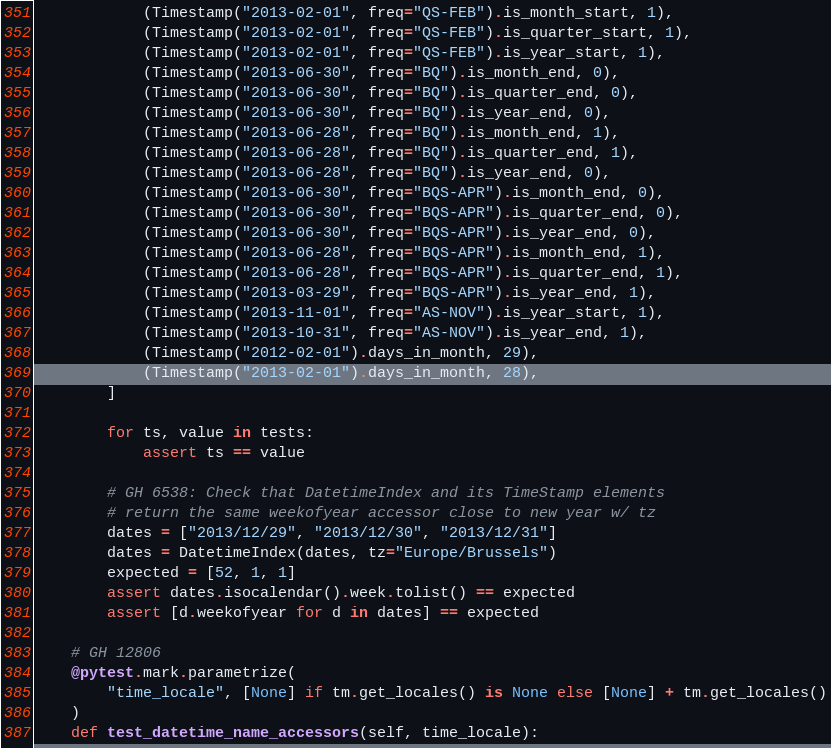Convert code to text. <code><loc_0><loc_0><loc_500><loc_500><_Python_>            (Timestamp("2013-02-01", freq="QS-FEB").is_month_start, 1),
            (Timestamp("2013-02-01", freq="QS-FEB").is_quarter_start, 1),
            (Timestamp("2013-02-01", freq="QS-FEB").is_year_start, 1),
            (Timestamp("2013-06-30", freq="BQ").is_month_end, 0),
            (Timestamp("2013-06-30", freq="BQ").is_quarter_end, 0),
            (Timestamp("2013-06-30", freq="BQ").is_year_end, 0),
            (Timestamp("2013-06-28", freq="BQ").is_month_end, 1),
            (Timestamp("2013-06-28", freq="BQ").is_quarter_end, 1),
            (Timestamp("2013-06-28", freq="BQ").is_year_end, 0),
            (Timestamp("2013-06-30", freq="BQS-APR").is_month_end, 0),
            (Timestamp("2013-06-30", freq="BQS-APR").is_quarter_end, 0),
            (Timestamp("2013-06-30", freq="BQS-APR").is_year_end, 0),
            (Timestamp("2013-06-28", freq="BQS-APR").is_month_end, 1),
            (Timestamp("2013-06-28", freq="BQS-APR").is_quarter_end, 1),
            (Timestamp("2013-03-29", freq="BQS-APR").is_year_end, 1),
            (Timestamp("2013-11-01", freq="AS-NOV").is_year_start, 1),
            (Timestamp("2013-10-31", freq="AS-NOV").is_year_end, 1),
            (Timestamp("2012-02-01").days_in_month, 29),
            (Timestamp("2013-02-01").days_in_month, 28),
        ]

        for ts, value in tests:
            assert ts == value

        # GH 6538: Check that DatetimeIndex and its TimeStamp elements
        # return the same weekofyear accessor close to new year w/ tz
        dates = ["2013/12/29", "2013/12/30", "2013/12/31"]
        dates = DatetimeIndex(dates, tz="Europe/Brussels")
        expected = [52, 1, 1]
        assert dates.isocalendar().week.tolist() == expected
        assert [d.weekofyear for d in dates] == expected

    # GH 12806
    @pytest.mark.parametrize(
        "time_locale", [None] if tm.get_locales() is None else [None] + tm.get_locales()
    )
    def test_datetime_name_accessors(self, time_locale):</code> 